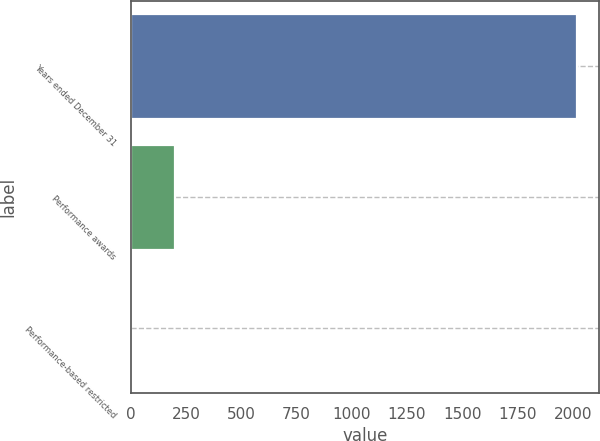Convert chart. <chart><loc_0><loc_0><loc_500><loc_500><bar_chart><fcel>Years ended December 31<fcel>Performance awards<fcel>Performance-based restricted<nl><fcel>2018<fcel>202.07<fcel>0.3<nl></chart> 